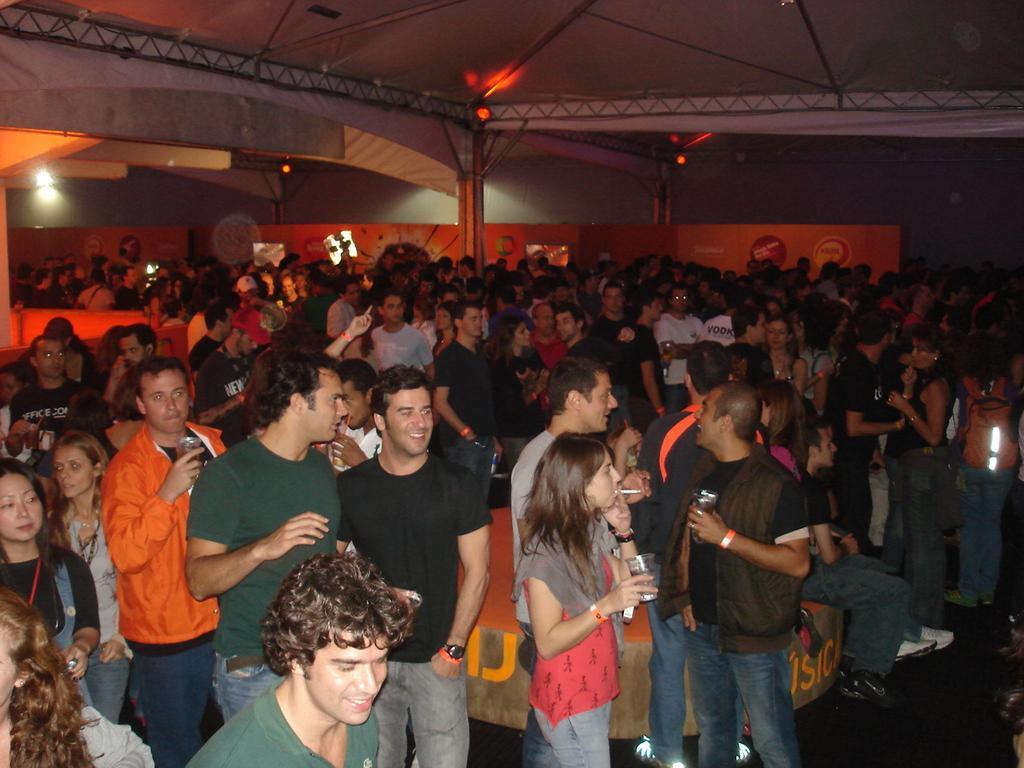In one or two sentences, can you explain what this image depicts? In this picture there are group of people standing. In the foreground there is a woman standing and holding the glass and she is smoking. At the back there is a board. At the top there are lights. At the bottom there is a floor and there is a sofa. 